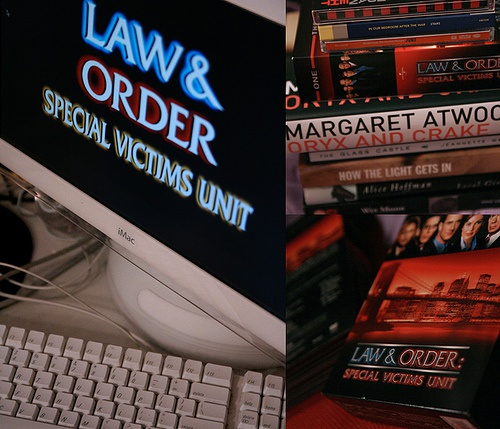Describe the objects in this image and their specific colors. I can see tv in black, darkgray, lightblue, and maroon tones, book in black, maroon, and brown tones, keyboard in black and gray tones, book in black, maroon, brown, and tan tones, and book in black, gray, darkgray, and brown tones in this image. 